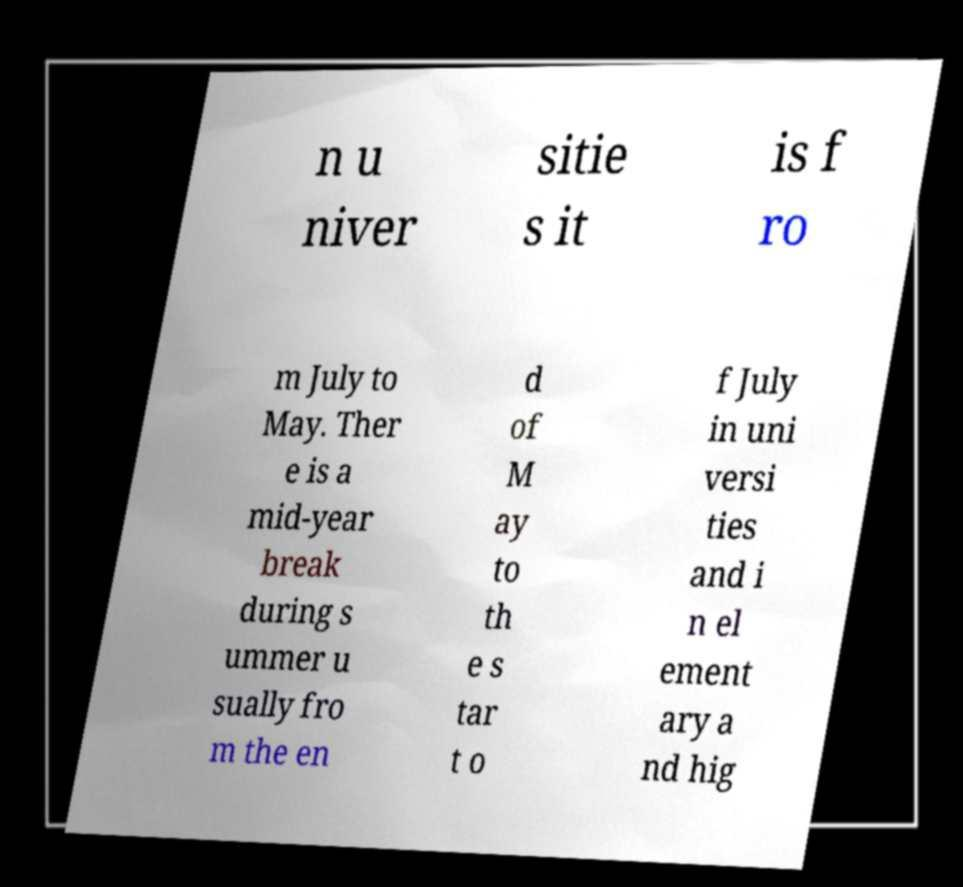There's text embedded in this image that I need extracted. Can you transcribe it verbatim? n u niver sitie s it is f ro m July to May. Ther e is a mid-year break during s ummer u sually fro m the en d of M ay to th e s tar t o f July in uni versi ties and i n el ement ary a nd hig 